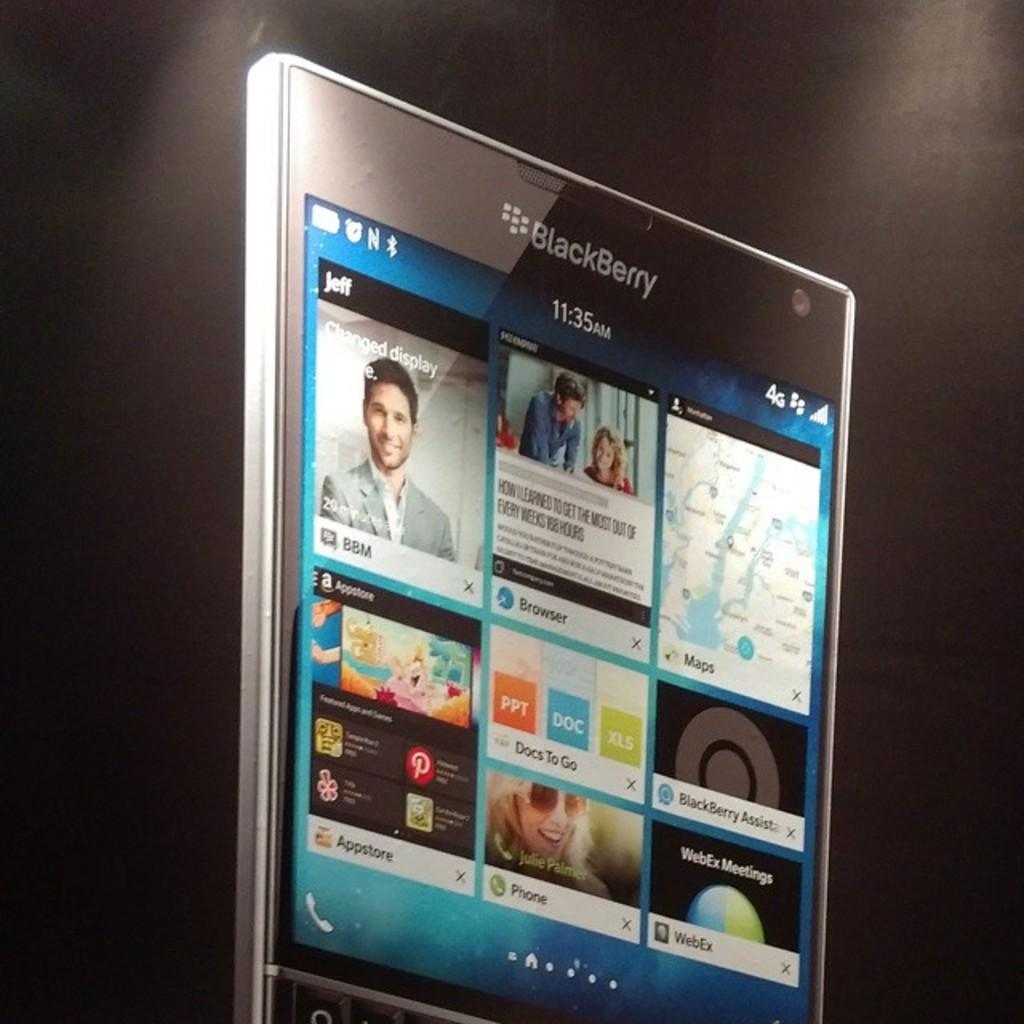What electronic device is visible in the picture? There is a mobile phone in the picture. What is displayed on the mobile phone's screen? The mobile phone's screen displays applications and icons. Where is the nearest cemetery to the location of the mobile phone in the image? The provided facts do not give any information about the location of the mobile phone or the presence of a cemetery, so it cannot be determined from the image. 